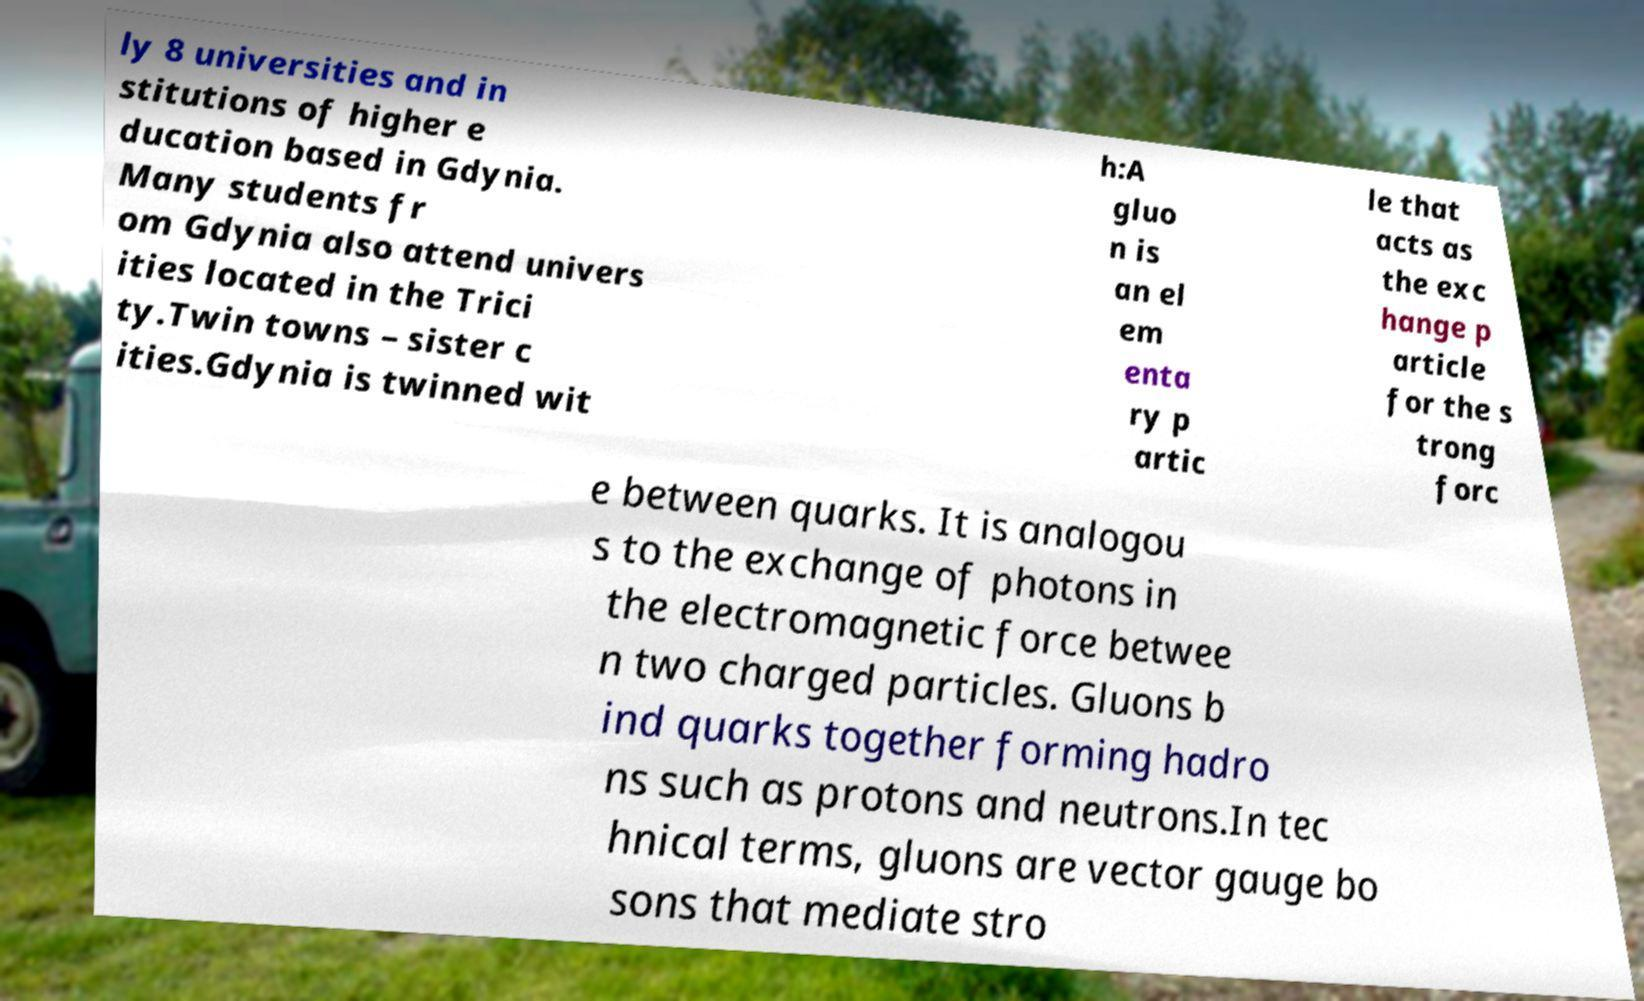There's text embedded in this image that I need extracted. Can you transcribe it verbatim? ly 8 universities and in stitutions of higher e ducation based in Gdynia. Many students fr om Gdynia also attend univers ities located in the Trici ty.Twin towns – sister c ities.Gdynia is twinned wit h:A gluo n is an el em enta ry p artic le that acts as the exc hange p article for the s trong forc e between quarks. It is analogou s to the exchange of photons in the electromagnetic force betwee n two charged particles. Gluons b ind quarks together forming hadro ns such as protons and neutrons.In tec hnical terms, gluons are vector gauge bo sons that mediate stro 